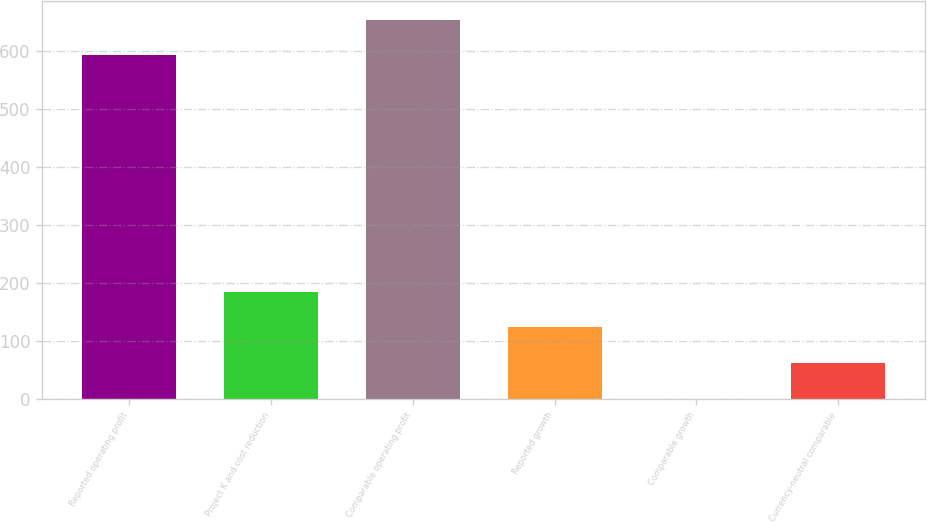<chart> <loc_0><loc_0><loc_500><loc_500><bar_chart><fcel>Reported operating profit<fcel>Project K and cost reduction<fcel>Comparable operating profit<fcel>Reported growth<fcel>Comparable growth<fcel>Currency-neutral comparable<nl><fcel>593<fcel>185.15<fcel>654.55<fcel>123.6<fcel>0.5<fcel>62.05<nl></chart> 